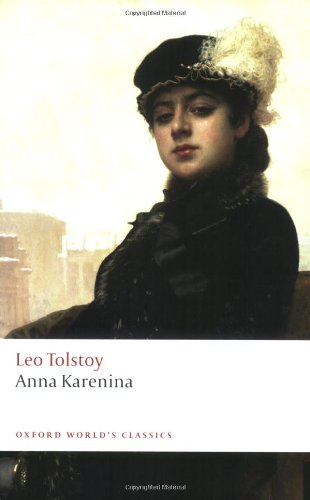Who is the author of this book? The author of the book featured in the image is Leo Tolstoy, a renowned Russian writer, who is famous for his deep, intricate narratives and profound character development. 'Anna Karenina' is one of his best-known novels. 